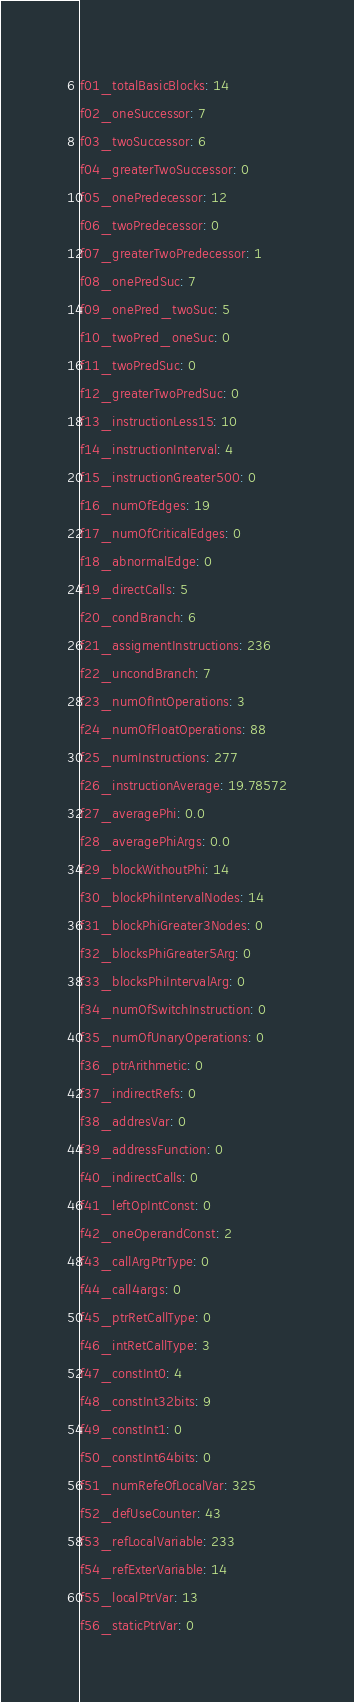Convert code to text. <code><loc_0><loc_0><loc_500><loc_500><_YAML_>f01_totalBasicBlocks: 14
f02_oneSuccessor: 7
f03_twoSuccessor: 6
f04_greaterTwoSuccessor: 0
f05_onePredecessor: 12
f06_twoPredecessor: 0
f07_greaterTwoPredecessor: 1
f08_onePredSuc: 7
f09_onePred_twoSuc: 5
f10_twoPred_oneSuc: 0
f11_twoPredSuc: 0
f12_greaterTwoPredSuc: 0
f13_instructionLess15: 10
f14_instructionInterval: 4
f15_instructionGreater500: 0
f16_numOfEdges: 19
f17_numOfCriticalEdges: 0
f18_abnormalEdge: 0
f19_directCalls: 5
f20_condBranch: 6
f21_assigmentInstructions: 236
f22_uncondBranch: 7
f23_numOfIntOperations: 3
f24_numOfFloatOperations: 88
f25_numInstructions: 277
f26_instructionAverage: 19.78572
f27_averagePhi: 0.0
f28_averagePhiArgs: 0.0
f29_blockWithoutPhi: 14
f30_blockPhiIntervalNodes: 14
f31_blockPhiGreater3Nodes: 0
f32_blocksPhiGreater5Arg: 0
f33_blocksPhiIntervalArg: 0
f34_numOfSwitchInstruction: 0
f35_numOfUnaryOperations: 0
f36_ptrArithmetic: 0
f37_indirectRefs: 0
f38_addresVar: 0
f39_addressFunction: 0
f40_indirectCalls: 0
f41_leftOpIntConst: 0
f42_oneOperandConst: 2
f43_callArgPtrType: 0
f44_call4args: 0
f45_ptrRetCallType: 0
f46_intRetCallType: 3
f47_constInt0: 4
f48_constInt32bits: 9
f49_constInt1: 0
f50_constInt64bits: 0
f51_numRefeOfLocalVar: 325
f52_defUseCounter: 43
f53_refLocalVariable: 233
f54_refExterVariable: 14
f55_localPtrVar: 13
f56_staticPtrVar: 0
</code> 